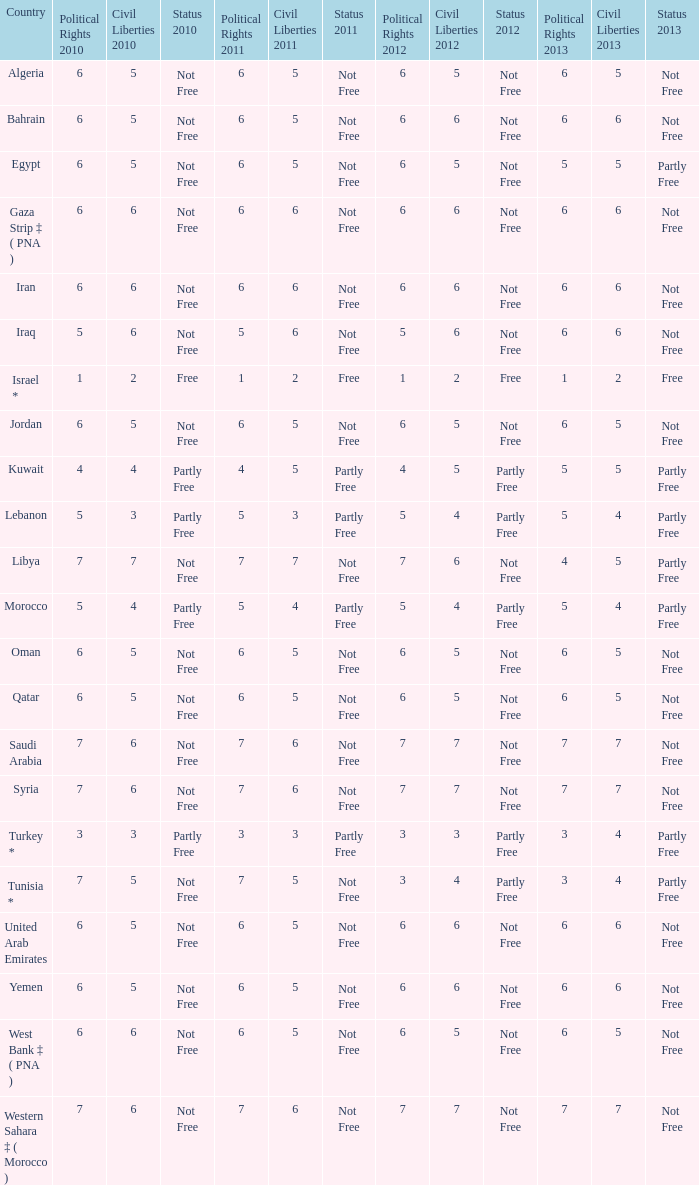How many civil liberties 2013 values are associated with a 2010 political rights value of 6, civil liberties 2012 values over 5, and political rights 2011 under 6? 0.0. 